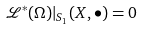Convert formula to latex. <formula><loc_0><loc_0><loc_500><loc_500>\mathcal { L } ^ { * } ( \Omega ) | _ { S _ { 1 } } ( X , \bullet ) = 0</formula> 